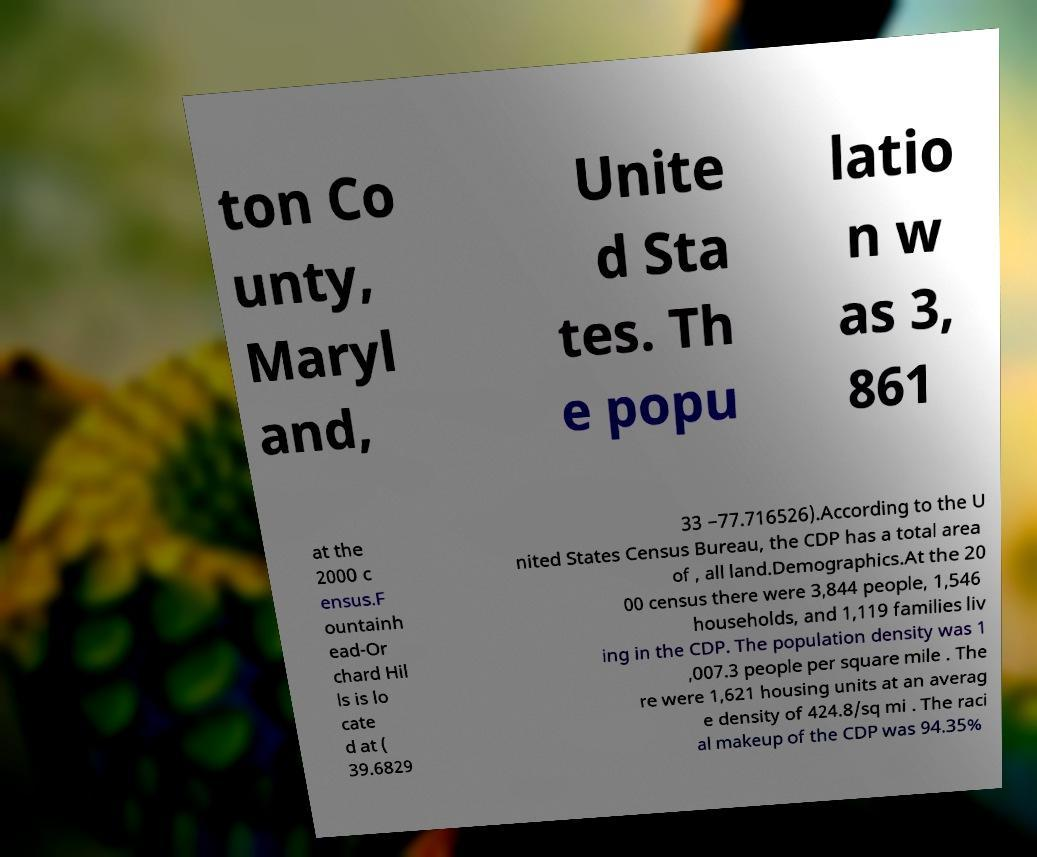I need the written content from this picture converted into text. Can you do that? ton Co unty, Maryl and, Unite d Sta tes. Th e popu latio n w as 3, 861 at the 2000 c ensus.F ountainh ead-Or chard Hil ls is lo cate d at ( 39.6829 33 −77.716526).According to the U nited States Census Bureau, the CDP has a total area of , all land.Demographics.At the 20 00 census there were 3,844 people, 1,546 households, and 1,119 families liv ing in the CDP. The population density was 1 ,007.3 people per square mile . The re were 1,621 housing units at an averag e density of 424.8/sq mi . The raci al makeup of the CDP was 94.35% 